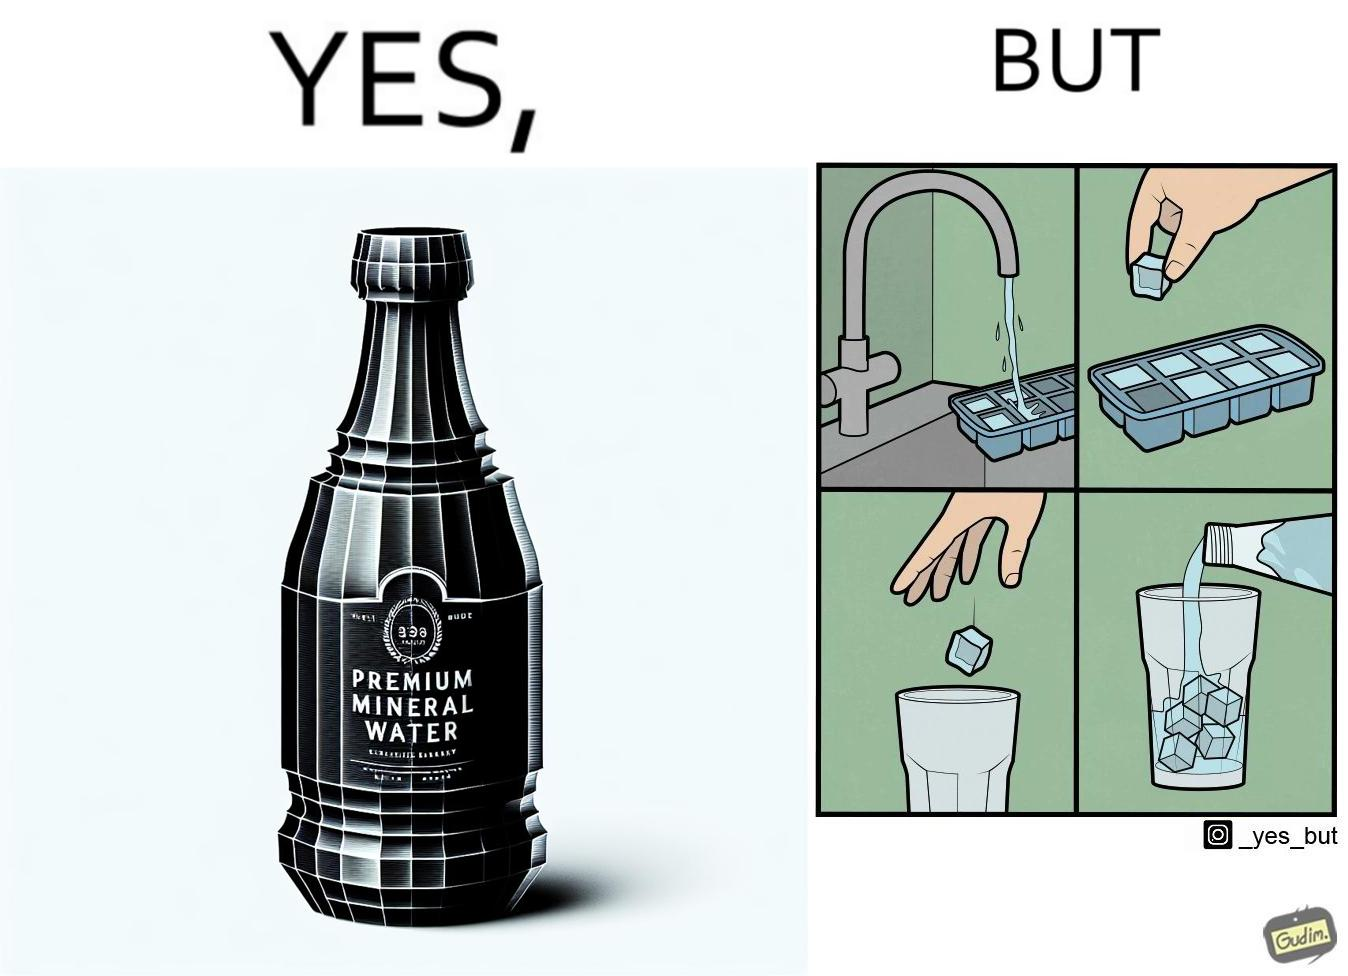What makes this image funny or satirical? This image is ironical, as a bottle of mineral water is being used along with ice cubes from tap water, while the sama tap water could have been instead used. 